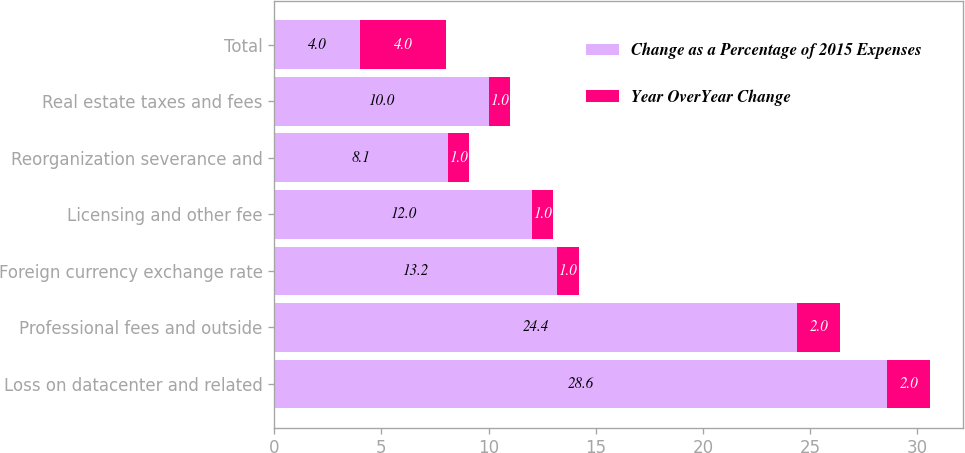Convert chart. <chart><loc_0><loc_0><loc_500><loc_500><stacked_bar_chart><ecel><fcel>Loss on datacenter and related<fcel>Professional fees and outside<fcel>Foreign currency exchange rate<fcel>Licensing and other fee<fcel>Reorganization severance and<fcel>Real estate taxes and fees<fcel>Total<nl><fcel>Change as a Percentage of 2015 Expenses<fcel>28.6<fcel>24.4<fcel>13.2<fcel>12<fcel>8.1<fcel>10<fcel>4<nl><fcel>Year OverYear Change<fcel>2<fcel>2<fcel>1<fcel>1<fcel>1<fcel>1<fcel>4<nl></chart> 